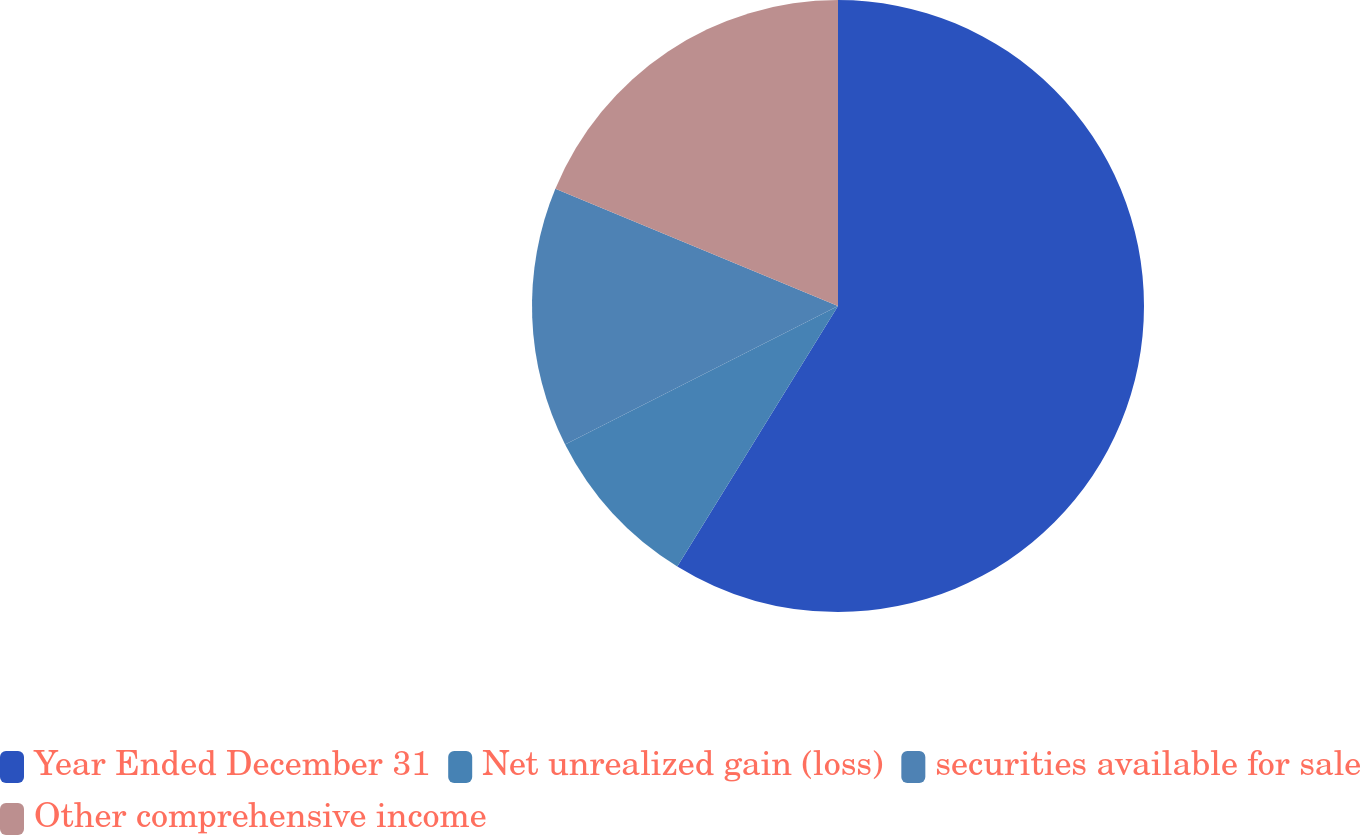Convert chart. <chart><loc_0><loc_0><loc_500><loc_500><pie_chart><fcel>Year Ended December 31<fcel>Net unrealized gain (loss)<fcel>securities available for sale<fcel>Other comprehensive income<nl><fcel>58.8%<fcel>8.73%<fcel>13.73%<fcel>18.74%<nl></chart> 